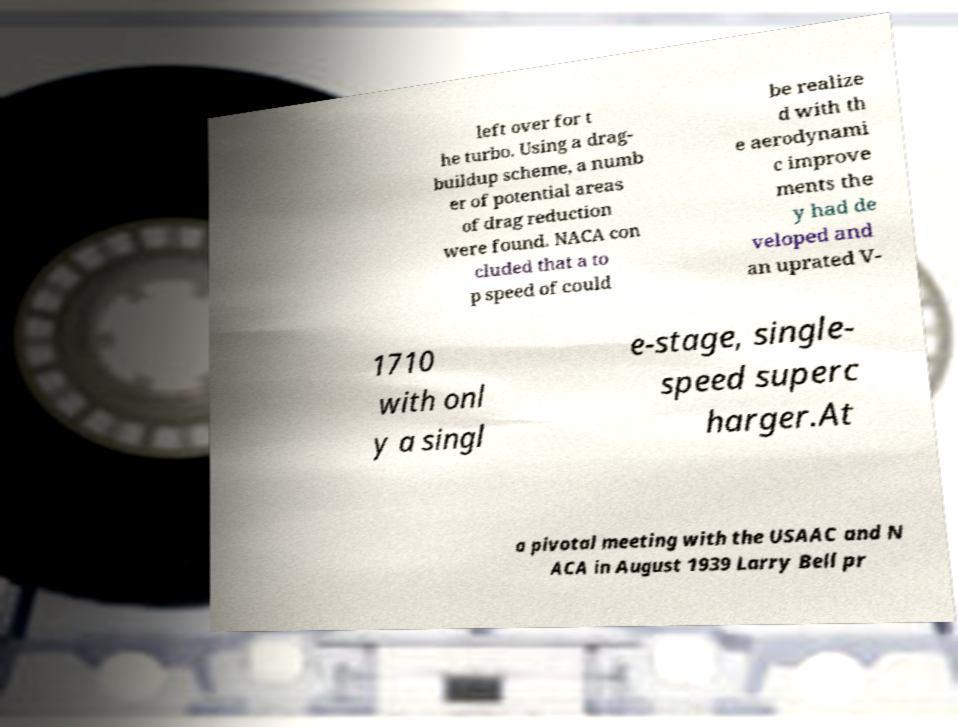Can you read and provide the text displayed in the image?This photo seems to have some interesting text. Can you extract and type it out for me? left over for t he turbo. Using a drag- buildup scheme, a numb er of potential areas of drag reduction were found. NACA con cluded that a to p speed of could be realize d with th e aerodynami c improve ments the y had de veloped and an uprated V- 1710 with onl y a singl e-stage, single- speed superc harger.At a pivotal meeting with the USAAC and N ACA in August 1939 Larry Bell pr 